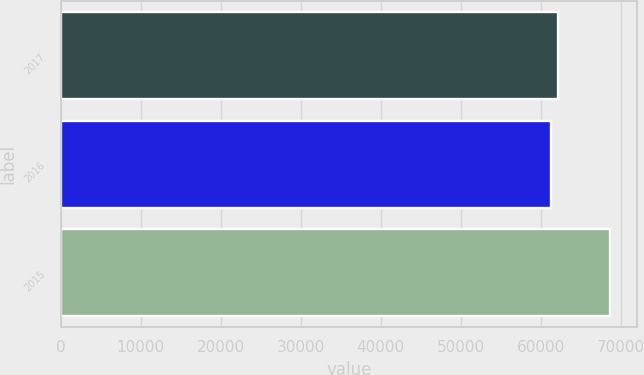Convert chart to OTSL. <chart><loc_0><loc_0><loc_500><loc_500><bar_chart><fcel>2017<fcel>2016<fcel>2015<nl><fcel>62098<fcel>61225<fcel>68595<nl></chart> 